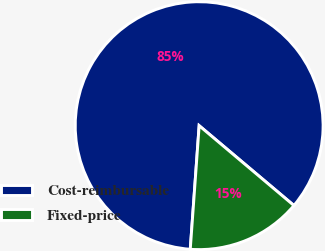<chart> <loc_0><loc_0><loc_500><loc_500><pie_chart><fcel>Cost-reimbursable<fcel>Fixed-price<nl><fcel>85.0%<fcel>15.0%<nl></chart> 